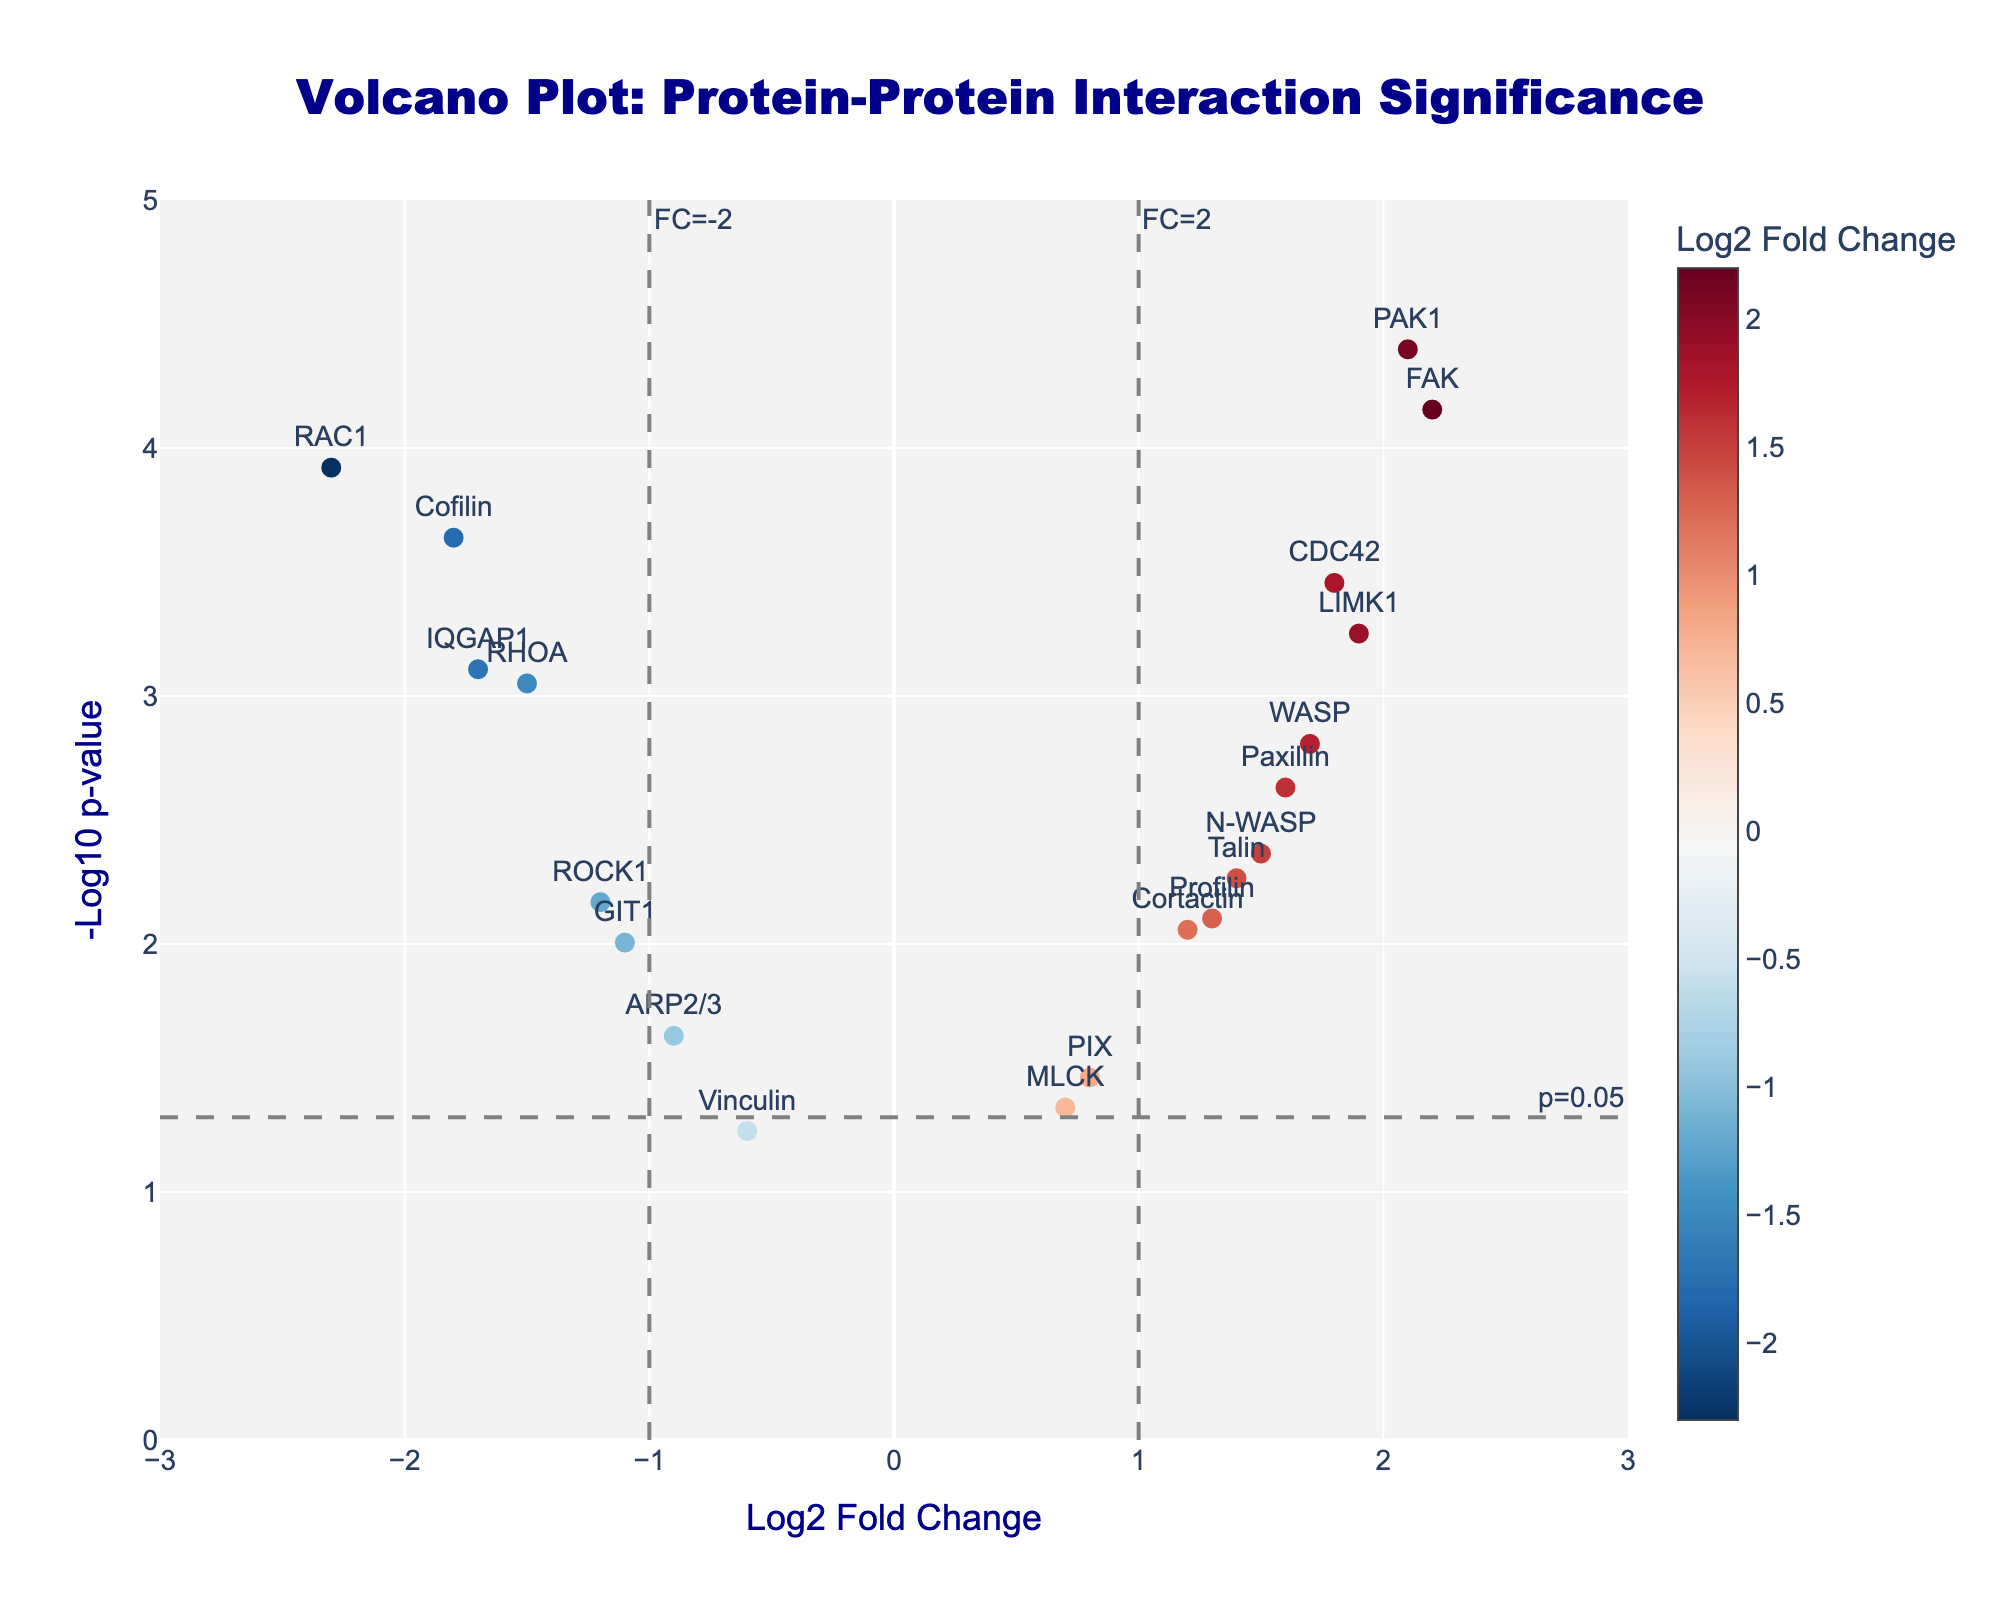What is the title of the plot? The title is typically displayed prominently at the top of the figure. In this plot, it is stated in the code to be "Volcano Plot: Protein-Protein Interaction Significance."
Answer: Volcano Plot: Protein-Protein Interaction Significance How many proteins have significant p-values below 0.05? In the plot, this information is visualized by data points above the dashed threshold line at -log10(p-value) = 1.3. Count the number of such data points.
Answer: 16 Which protein has the highest fold change? To find this, look for the data point with the highest log2 fold change value on the x-axis. Based on the data provided, you would find the protein at the furthest right.
Answer: FAK Which protein has the lowest p-value? The lowest p-value corresponds to the highest -log10(p-value). Look for the highest point on the y-axis, which according to the data, is the protein PAK1.
Answer: PAK1 How many proteins show a log2 fold change greater than 1? Locate the data points positioned on the right half of the plot, specifically those beyond the vertical threshold line at x=1. Count these points.
Answer: 7 Is the protein "Cofilin" upregulated or downregulated? Look at the log2 fold change value for "Cofilin." If it's negative, it's downregulated; if positive, it's upregulated. In this case, it's -1.8 which is negative.
Answer: Downregulated What is the log2 fold change and p-value for the protein "RAF1"? Cross-reference the provided data or hover over its label on the plot to see the log2 fold change and p-value details.
Answer: Not available/not in the dataset Which protein has a similar significance (p-value) to "IQGAP1" but a different log2 fold change? Find "IQGAP1" and identify the y-axis value corresponding to its significance. Compare log2 fold changes of nearby points with the same y-value. "Cofilin" has a similar p-value (-0.78 vs -0.78 log10 p-value) but a different log2 fold change.
Answer: Cofilin What is the average log2 fold change of downregulated proteins? Identify all proteins with negative log2 fold change values, sum their log2 fold changes, and divide by the number of such proteins. Sum of log2 fold changes for downregulated proteins (-2.3, -1.5, -0.9, -1.2, -1.8, -1.1, -1.7, -0.6) is -11.1. There are 8 proteins, so average = -11.1 / 8.
Answer: -1.39 